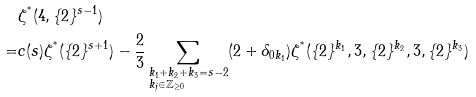<formula> <loc_0><loc_0><loc_500><loc_500>& \zeta ^ { ^ { * } } ( 4 , \{ 2 \} ^ { s - 1 } ) \\ = & c ( s ) \zeta ^ { ^ { * } } ( \{ 2 \} ^ { s + 1 } ) - \frac { 2 } { 3 } \sum _ { \begin{subarray} { c } k _ { 1 } + k _ { 2 } + k _ { 3 } = s - 2 \\ k _ { j } \in \mathbb { Z } _ { \geq 0 } \end{subarray} } ( 2 + \delta _ { 0 k _ { 1 } } ) \zeta ^ { ^ { * } } ( \{ 2 \} ^ { k _ { 1 } } , 3 , \{ 2 \} ^ { k _ { 2 } } , 3 , \{ 2 \} ^ { k _ { 3 } } )</formula> 